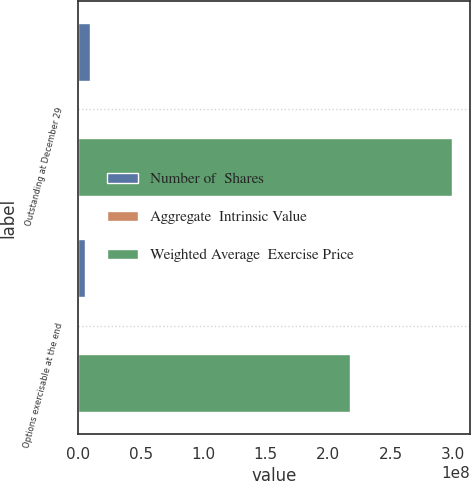Convert chart to OTSL. <chart><loc_0><loc_0><loc_500><loc_500><stacked_bar_chart><ecel><fcel>Outstanding at December 29<fcel>Options exercisable at the end<nl><fcel>Number of  Shares<fcel>9.14556e+06<fcel>5.42396e+06<nl><fcel>Aggregate  Intrinsic Value<fcel>24.94<fcel>17.51<nl><fcel>Weighted Average  Exercise Price<fcel>2.98745e+08<fcel>2.17383e+08<nl></chart> 